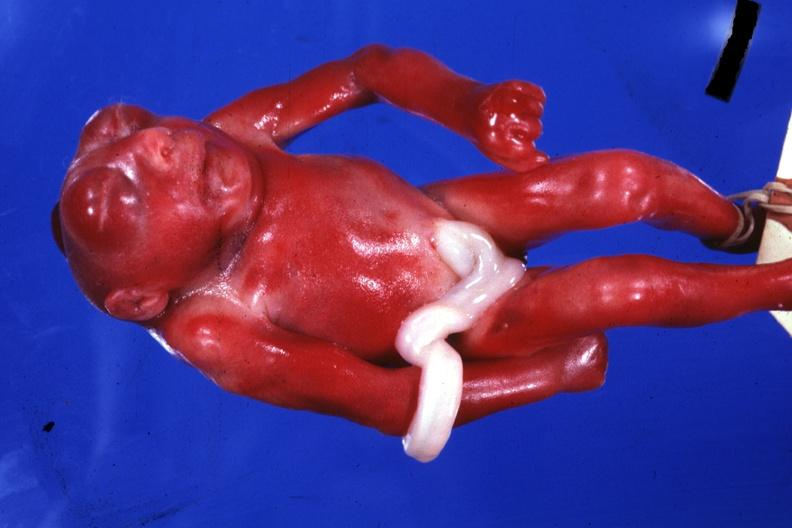does pus in test tube show whole body small fetus typical?
Answer the question using a single word or phrase. No 